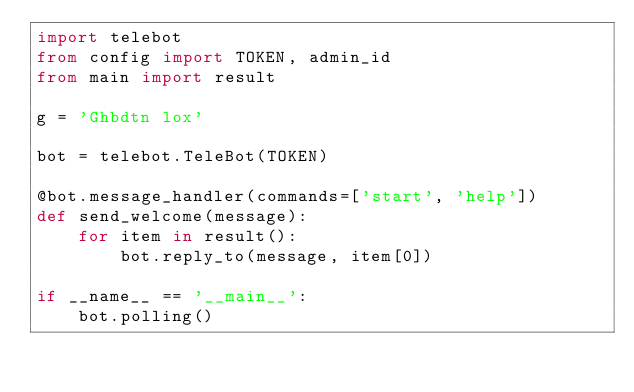<code> <loc_0><loc_0><loc_500><loc_500><_Python_>import telebot
from config import TOKEN, admin_id
from main import result

g = 'Ghbdtn lox'

bot = telebot.TeleBot(TOKEN)

@bot.message_handler(commands=['start', 'help'])
def send_welcome(message):
	for item in result():
		bot.reply_to(message, item[0])

if __name__ == '__main__':
    bot.polling()</code> 